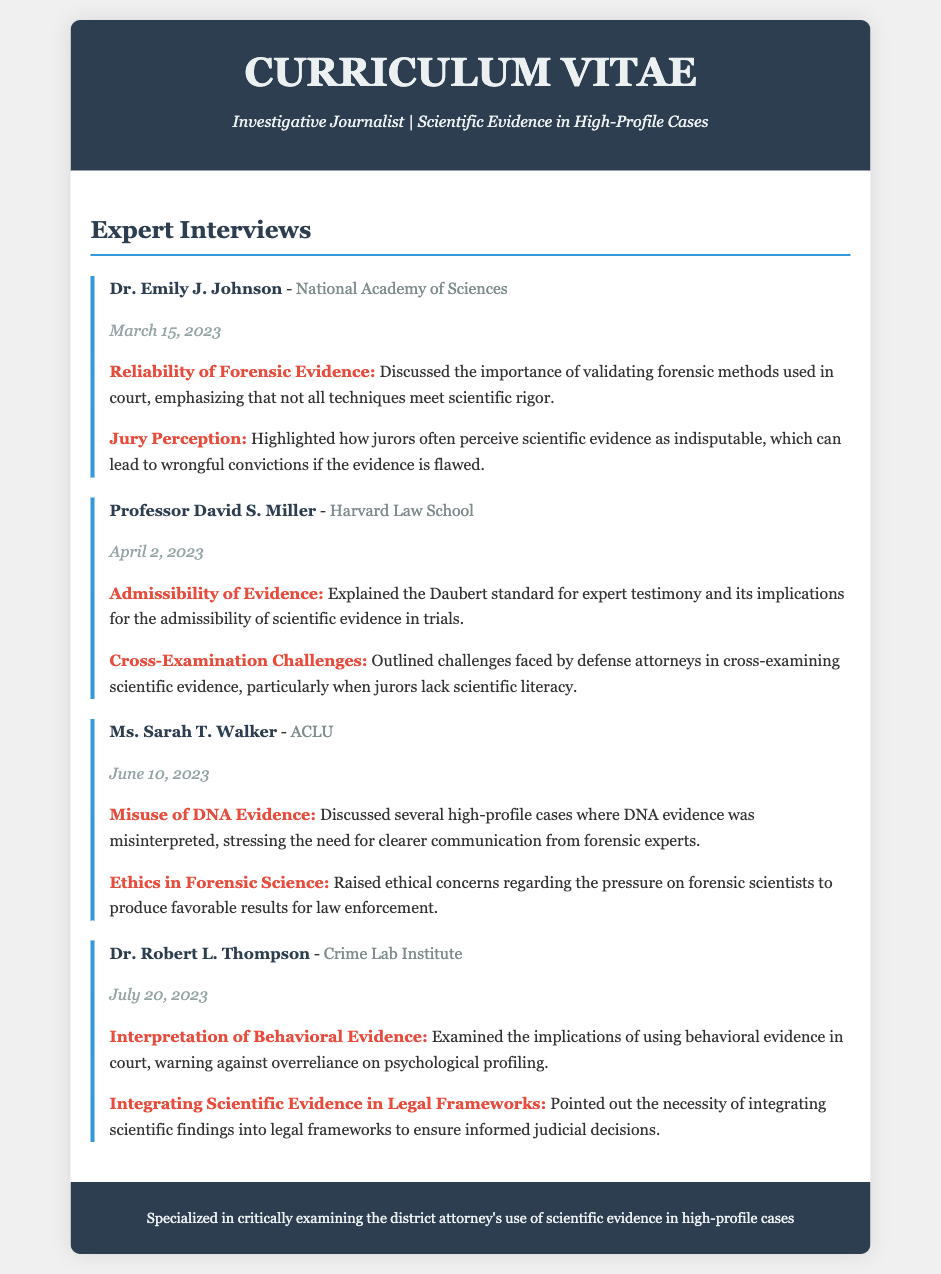What is the name of the first interviewee? The first interviewee listed in the document is Dr. Emily J. Johnson.
Answer: Dr. Emily J. Johnson What organization is Dr. Robert L. Thompson affiliated with? Dr. Robert L. Thompson is affiliated with the Crime Lab Institute.
Answer: Crime Lab Institute When was the interview with Ms. Sarah T. Walker conducted? The interview with Ms. Sarah T. Walker took place on June 10, 2023.
Answer: June 10, 2023 What is the key topic discussed by Professor David S. Miller? Professor David S. Miller discussed the Daubert standard for expert testimony.
Answer: Daubert standard for expert testimony Which ethical concern was raised by Ms. Sarah T. Walker? Ms. Sarah T. Walker raised ethical concerns regarding the pressure on forensic scientists.
Answer: Pressure on forensic scientists What implication does Dr. Emily J. Johnson highlight regarding jury perceptions? Dr. Emily J. Johnson highlights that jurors perceive scientific evidence as indisputable, leading to wrongful convictions.
Answer: Wrongful convictions Which type of evidence did Dr. Robert L. Thompson examine? Dr. Robert L. Thompson examined behavioral evidence in court.
Answer: Behavioral evidence How many key points did Dr. Emily J. Johnson discuss? Dr. Emily J. Johnson discussed two key points.
Answer: Two key points What is the primary specialization of the journalist? The journalist specializes in the examination of district attorneys' use of scientific evidence in high-profile cases.
Answer: Examination of district attorneys' use of scientific evidence 